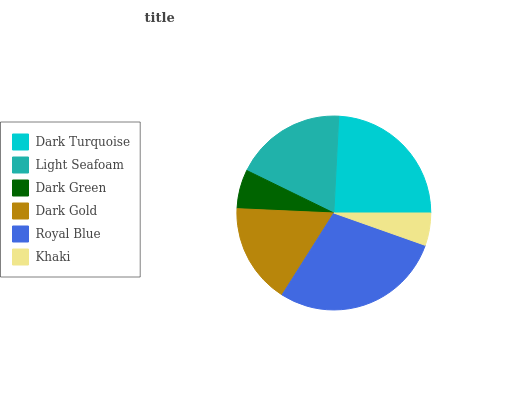Is Khaki the minimum?
Answer yes or no. Yes. Is Royal Blue the maximum?
Answer yes or no. Yes. Is Light Seafoam the minimum?
Answer yes or no. No. Is Light Seafoam the maximum?
Answer yes or no. No. Is Dark Turquoise greater than Light Seafoam?
Answer yes or no. Yes. Is Light Seafoam less than Dark Turquoise?
Answer yes or no. Yes. Is Light Seafoam greater than Dark Turquoise?
Answer yes or no. No. Is Dark Turquoise less than Light Seafoam?
Answer yes or no. No. Is Light Seafoam the high median?
Answer yes or no. Yes. Is Dark Gold the low median?
Answer yes or no. Yes. Is Dark Gold the high median?
Answer yes or no. No. Is Dark Turquoise the low median?
Answer yes or no. No. 